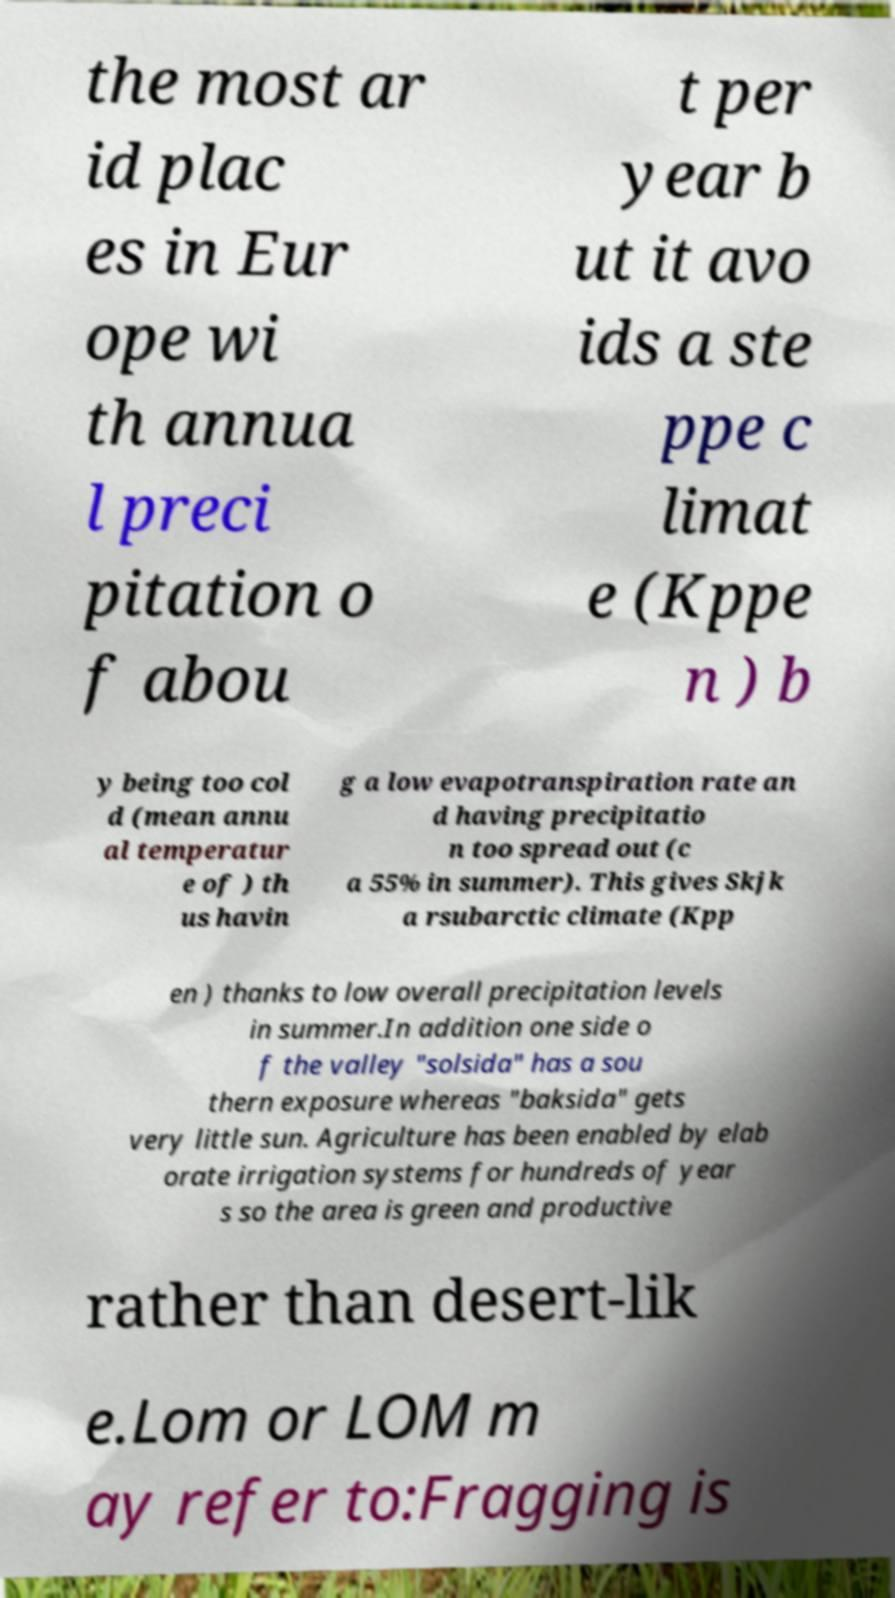Can you read and provide the text displayed in the image?This photo seems to have some interesting text. Can you extract and type it out for me? the most ar id plac es in Eur ope wi th annua l preci pitation o f abou t per year b ut it avo ids a ste ppe c limat e (Kppe n ) b y being too col d (mean annu al temperatur e of ) th us havin g a low evapotranspiration rate an d having precipitatio n too spread out (c a 55% in summer). This gives Skjk a rsubarctic climate (Kpp en ) thanks to low overall precipitation levels in summer.In addition one side o f the valley "solsida" has a sou thern exposure whereas "baksida" gets very little sun. Agriculture has been enabled by elab orate irrigation systems for hundreds of year s so the area is green and productive rather than desert-lik e.Lom or LOM m ay refer to:Fragging is 